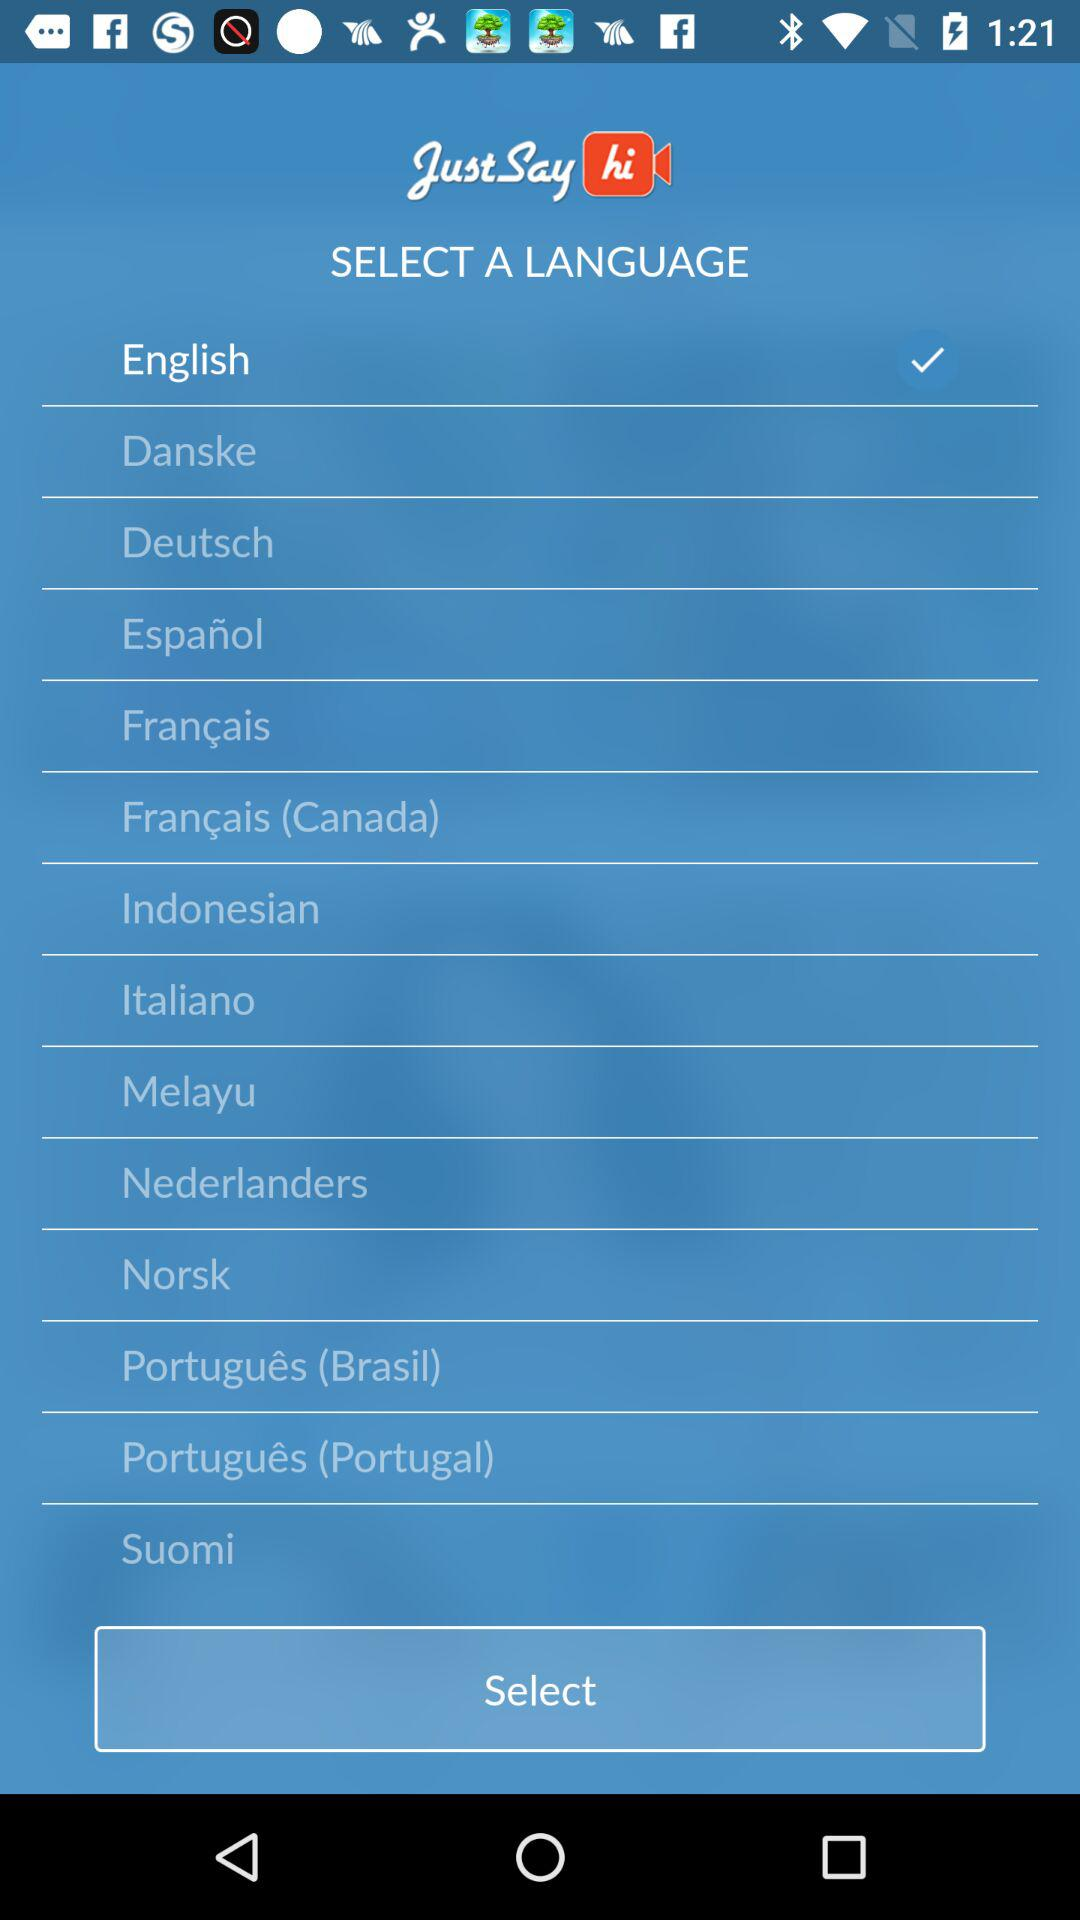How many languages are available for selection?
Answer the question using a single word or phrase. 14 